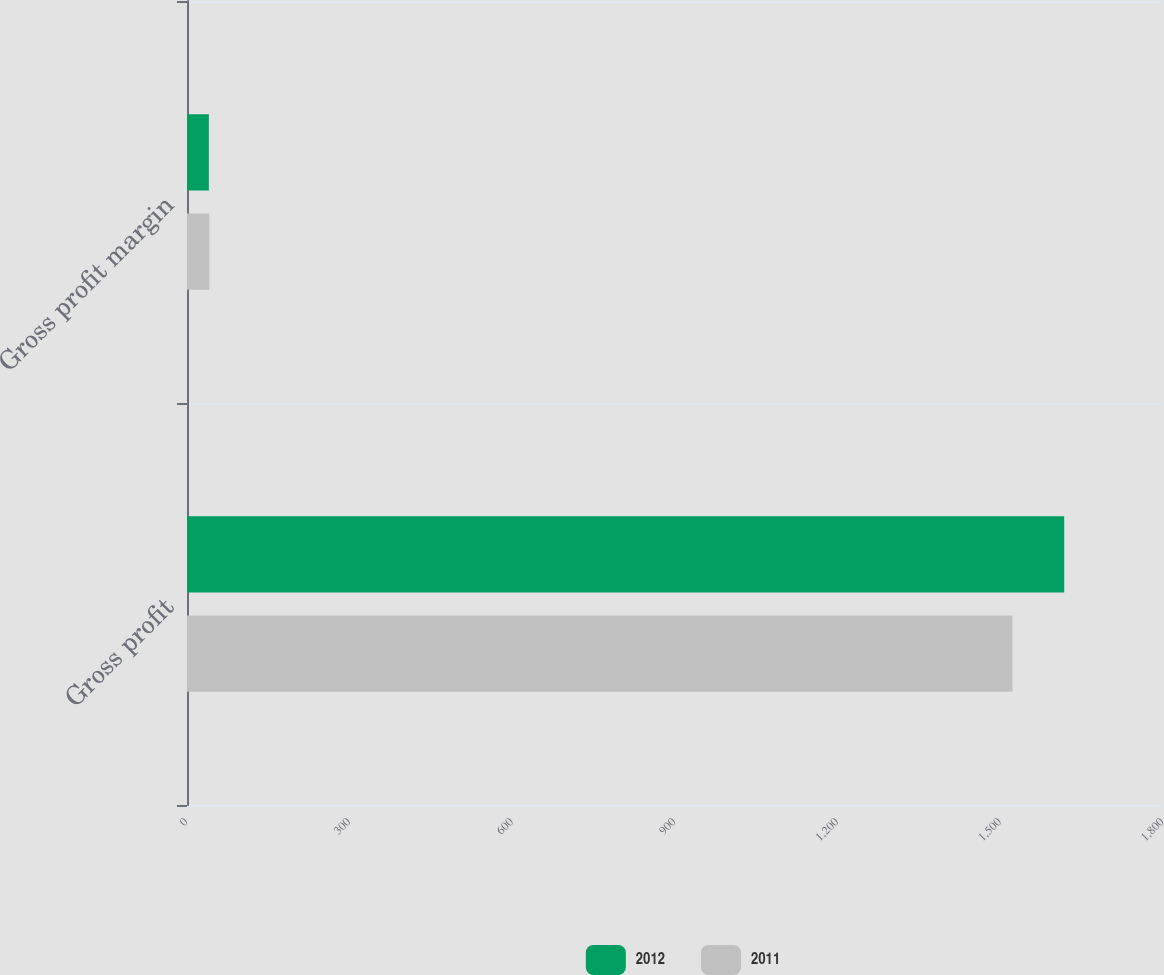<chart> <loc_0><loc_0><loc_500><loc_500><stacked_bar_chart><ecel><fcel>Gross profit<fcel>Gross profit margin<nl><fcel>2012<fcel>1617.8<fcel>40.3<nl><fcel>2011<fcel>1522.5<fcel>41.2<nl></chart> 